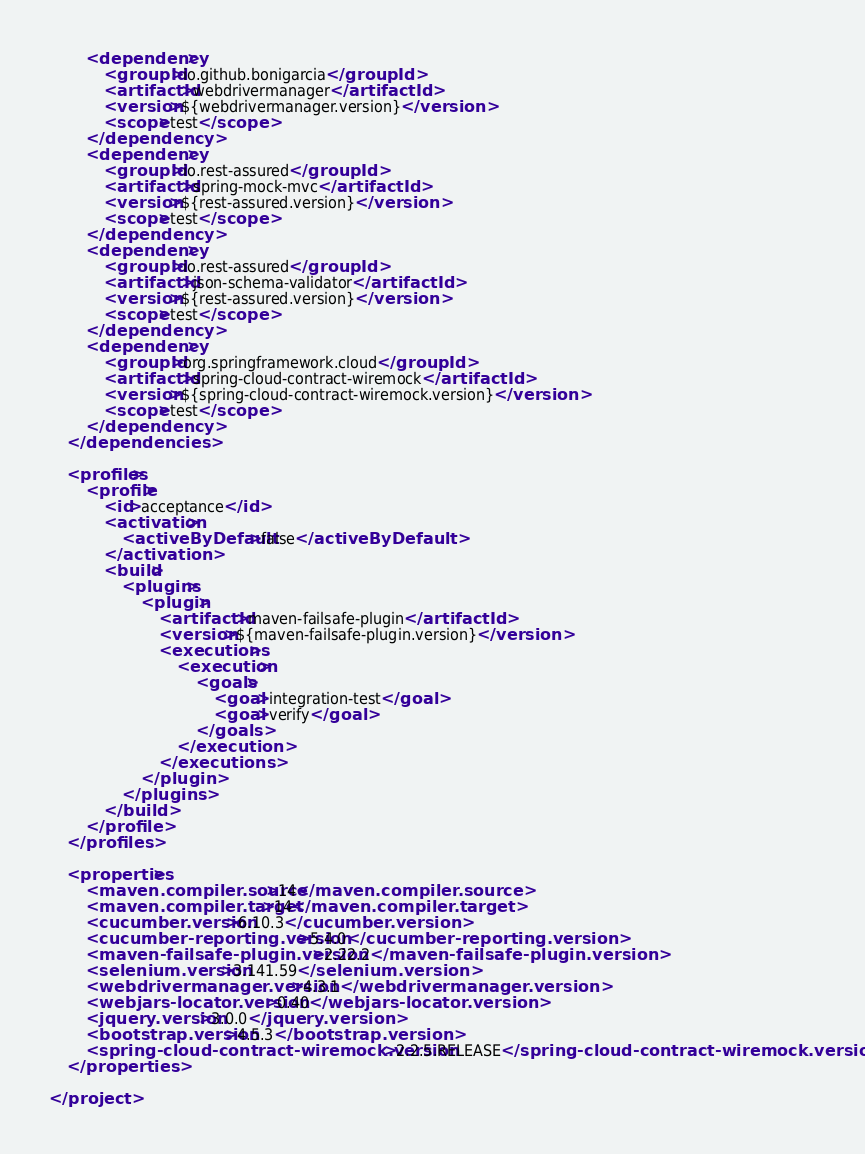<code> <loc_0><loc_0><loc_500><loc_500><_XML_>        <dependency>
            <groupId>io.github.bonigarcia</groupId>
            <artifactId>webdrivermanager</artifactId>
            <version>${webdrivermanager.version}</version>
            <scope>test</scope>
        </dependency>
        <dependency>
            <groupId>io.rest-assured</groupId>
            <artifactId>spring-mock-mvc</artifactId>
            <version>${rest-assured.version}</version>
            <scope>test</scope>
        </dependency>
        <dependency>
            <groupId>io.rest-assured</groupId>
            <artifactId>json-schema-validator</artifactId>
            <version>${rest-assured.version}</version>
            <scope>test</scope>
        </dependency>
        <dependency>
            <groupId>org.springframework.cloud</groupId>
            <artifactId>spring-cloud-contract-wiremock</artifactId>
            <version>${spring-cloud-contract-wiremock.version}</version>
            <scope>test</scope>
        </dependency>
    </dependencies>

    <profiles>
        <profile>
            <id>acceptance</id>
            <activation>
                <activeByDefault>false</activeByDefault>
            </activation>
            <build>
                <plugins>
                    <plugin>
                        <artifactId>maven-failsafe-plugin</artifactId>
                        <version>${maven-failsafe-plugin.version}</version>
                        <executions>
                            <execution>
                                <goals>
                                    <goal>integration-test</goal>
                                    <goal>verify</goal>
                                </goals>
                            </execution>
                        </executions>
                    </plugin>
                </plugins>
            </build>
        </profile>
    </profiles>

    <properties>
        <maven.compiler.source>14</maven.compiler.source>
        <maven.compiler.target>14</maven.compiler.target>
        <cucumber.version>6.10.3</cucumber.version>
        <cucumber-reporting.version>5.4.0</cucumber-reporting.version>
        <maven-failsafe-plugin.version>2.22.2</maven-failsafe-plugin.version>
        <selenium.version>3.141.59</selenium.version>
        <webdrivermanager.version>4.3.1</webdrivermanager.version>
        <webjars-locator.version>0.40</webjars-locator.version>
        <jquery.version>3.0.0</jquery.version>
        <bootstrap.version>4.5.3</bootstrap.version>
        <spring-cloud-contract-wiremock.version>2.2.5.RELEASE</spring-cloud-contract-wiremock.version>
    </properties>

</project></code> 